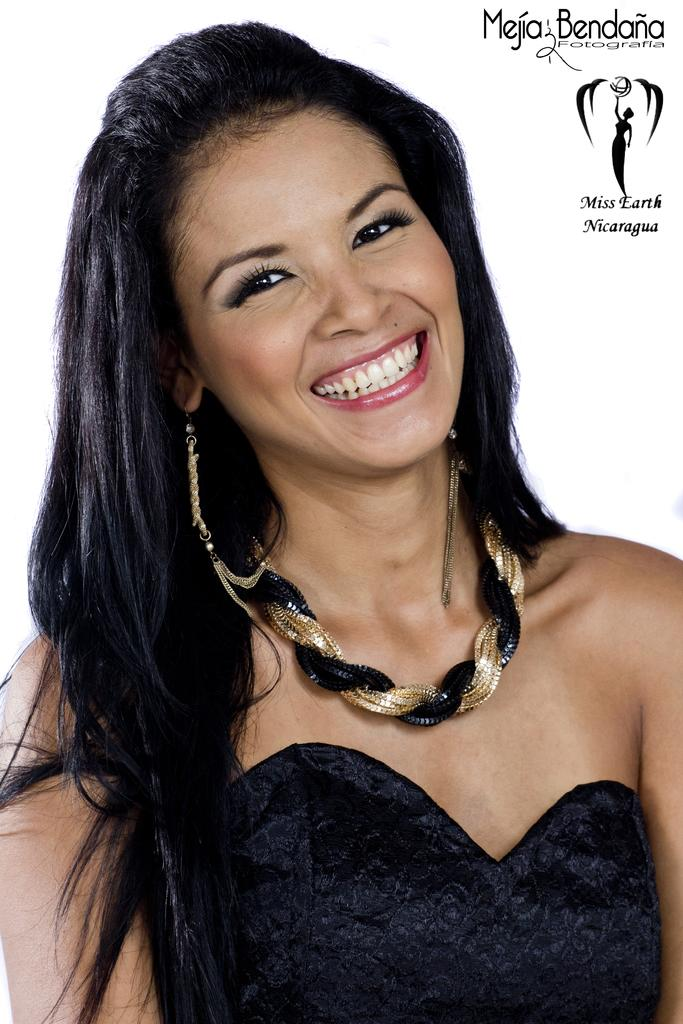Who is the main subject in the image? There is a woman in the image. What is the woman wearing in the image? The woman is wearing a black dress and a necklace. What is the woman's facial expression in the image? The woman is smiling in the image. How many brothers does the woman have in the image? There is no information about the woman's brothers in the image. What type of machine is the woman operating in the image? There is no machine present in the image. 